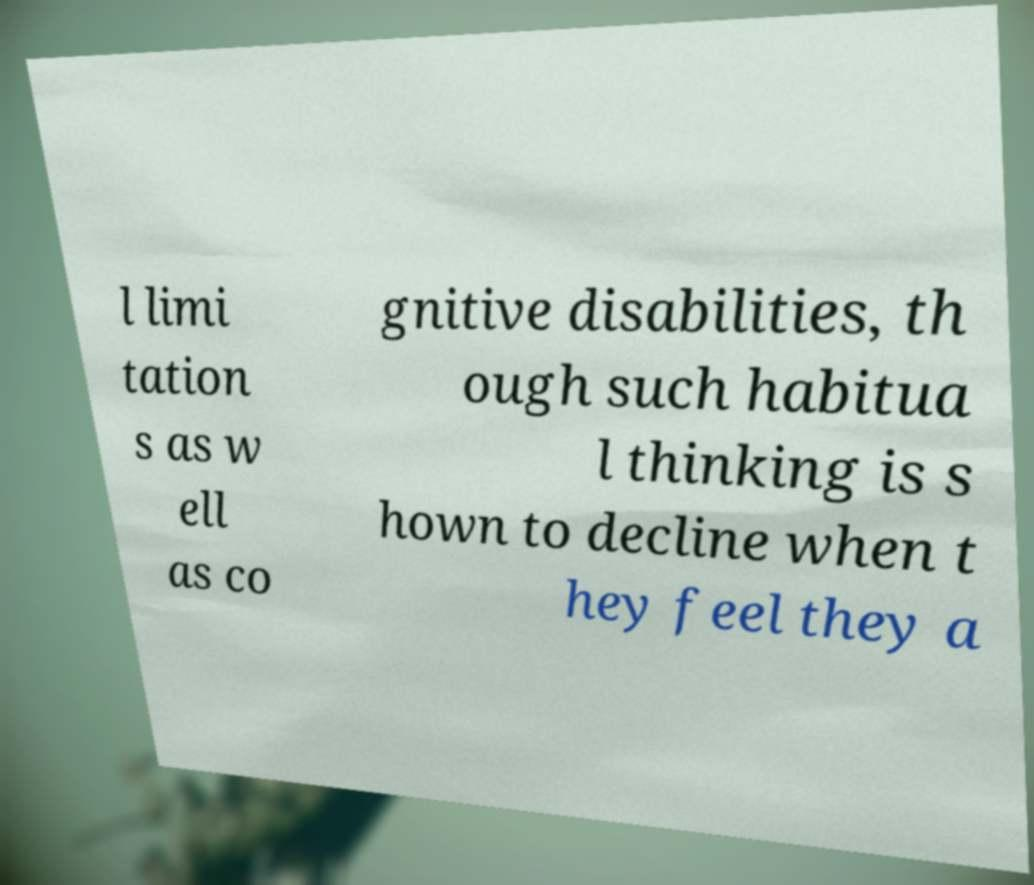I need the written content from this picture converted into text. Can you do that? l limi tation s as w ell as co gnitive disabilities, th ough such habitua l thinking is s hown to decline when t hey feel they a 